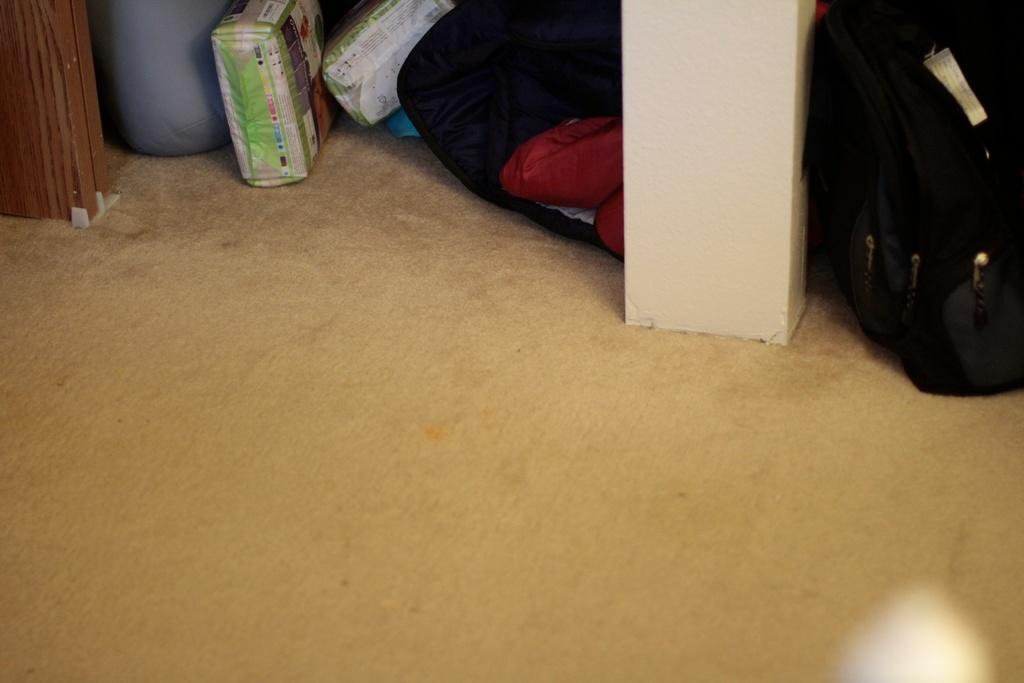What objects are present in the image that resemble containers for carrying items? There are bags in the image. What color can be seen on some of the objects in the image? There are red-colored things in the image. What is the color of the box in the image? There is a white-colored box in the image. Can you describe any other items in the image that are not specified? There are other unspecified items in the image. How many cherries are on the spoon in the image? There is no spoon or cherry present in the image. What type of ant can be seen crawling on the red-colored items in the image? There are no ants present in the image. 